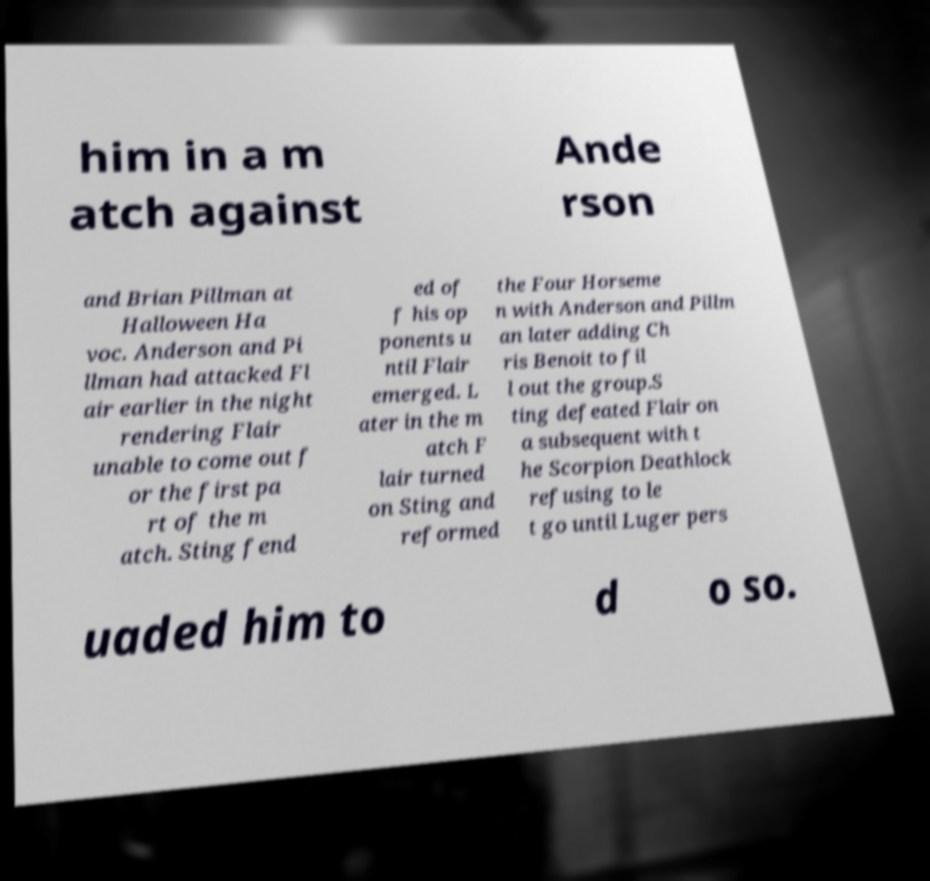I need the written content from this picture converted into text. Can you do that? him in a m atch against Ande rson and Brian Pillman at Halloween Ha voc. Anderson and Pi llman had attacked Fl air earlier in the night rendering Flair unable to come out f or the first pa rt of the m atch. Sting fend ed of f his op ponents u ntil Flair emerged. L ater in the m atch F lair turned on Sting and reformed the Four Horseme n with Anderson and Pillm an later adding Ch ris Benoit to fil l out the group.S ting defeated Flair on a subsequent with t he Scorpion Deathlock refusing to le t go until Luger pers uaded him to d o so. 